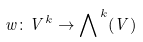Convert formula to latex. <formula><loc_0><loc_0><loc_500><loc_500>w \colon V ^ { k } \to { \bigwedge } ^ { \, k } ( V )</formula> 